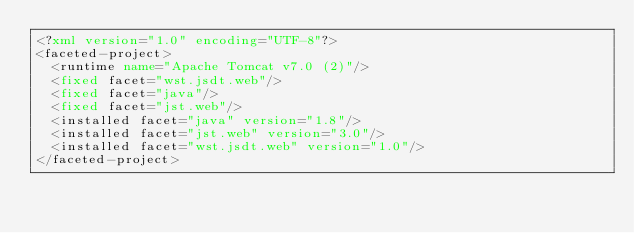Convert code to text. <code><loc_0><loc_0><loc_500><loc_500><_XML_><?xml version="1.0" encoding="UTF-8"?>
<faceted-project>
  <runtime name="Apache Tomcat v7.0 (2)"/>
  <fixed facet="wst.jsdt.web"/>
  <fixed facet="java"/>
  <fixed facet="jst.web"/>
  <installed facet="java" version="1.8"/>
  <installed facet="jst.web" version="3.0"/>
  <installed facet="wst.jsdt.web" version="1.0"/>
</faceted-project>
</code> 